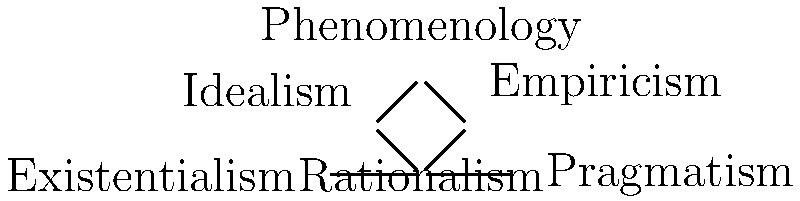In the network graph of philosophical schools of thought, which school serves as the central node, connecting directly to the most other schools, and what might this suggest about its role in the development of philosophy? To answer this question, we need to analyze the network graph and follow these steps:

1. Identify all the schools of thought represented in the graph:
   - Rationalism
   - Empiricism
   - Idealism
   - Phenomenology
   - Existentialism
   - Pragmatism

2. Count the number of direct connections for each school:
   - Rationalism: 4 connections (to Empiricism, Idealism, Existentialism, and Pragmatism)
   - Empiricism: 2 connections (to Rationalism and Phenomenology)
   - Idealism: 2 connections (to Rationalism and Phenomenology)
   - Phenomenology: 2 connections (to Empiricism and Idealism)
   - Existentialism: 2 connections (to Rationalism and Pragmatism)
   - Pragmatism: 2 connections (to Rationalism and Existentialism)

3. Identify the school with the most direct connections:
   Rationalism has the most connections (4), making it the central node in the network.

4. Interpret the significance of Rationalism's central position:
   The central position of Rationalism suggests that it plays a crucial role in the development of philosophy. It implies that Rationalism has influenced or been influenced by a wide range of other philosophical schools. This central position may indicate that Rationalism has been a foundational or pivotal school of thought, serving as a starting point or point of contention for many other philosophical perspectives.
Answer: Rationalism; it suggests a foundational role in philosophical development. 